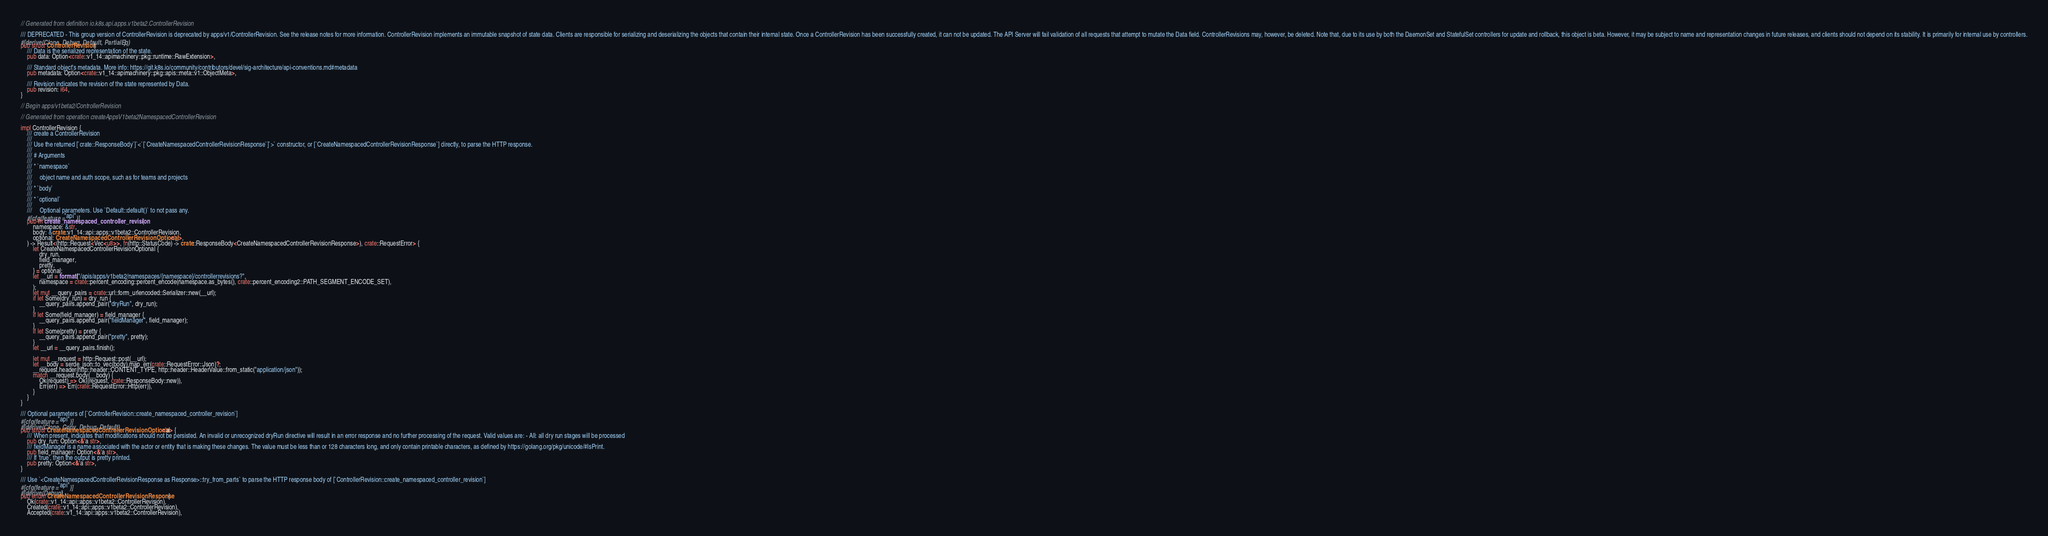<code> <loc_0><loc_0><loc_500><loc_500><_Rust_>// Generated from definition io.k8s.api.apps.v1beta2.ControllerRevision

/// DEPRECATED - This group version of ControllerRevision is deprecated by apps/v1/ControllerRevision. See the release notes for more information. ControllerRevision implements an immutable snapshot of state data. Clients are responsible for serializing and deserializing the objects that contain their internal state. Once a ControllerRevision has been successfully created, it can not be updated. The API Server will fail validation of all requests that attempt to mutate the Data field. ControllerRevisions may, however, be deleted. Note that, due to its use by both the DaemonSet and StatefulSet controllers for update and rollback, this object is beta. However, it may be subject to name and representation changes in future releases, and clients should not depend on its stability. It is primarily for internal use by controllers.
#[derive(Clone, Debug, Default, PartialEq)]
pub struct ControllerRevision {
    /// Data is the serialized representation of the state.
    pub data: Option<crate::v1_14::apimachinery::pkg::runtime::RawExtension>,

    /// Standard object's metadata. More info: https://git.k8s.io/community/contributors/devel/sig-architecture/api-conventions.md#metadata
    pub metadata: Option<crate::v1_14::apimachinery::pkg::apis::meta::v1::ObjectMeta>,

    /// Revision indicates the revision of the state represented by Data.
    pub revision: i64,
}

// Begin apps/v1beta2/ControllerRevision

// Generated from operation createAppsV1beta2NamespacedControllerRevision

impl ControllerRevision {
    /// create a ControllerRevision
    ///
    /// Use the returned [`crate::ResponseBody`]`<`[`CreateNamespacedControllerRevisionResponse`]`>` constructor, or [`CreateNamespacedControllerRevisionResponse`] directly, to parse the HTTP response.
    ///
    /// # Arguments
    ///
    /// * `namespace`
    ///
    ///     object name and auth scope, such as for teams and projects
    ///
    /// * `body`
    ///
    /// * `optional`
    ///
    ///     Optional parameters. Use `Default::default()` to not pass any.
    #[cfg(feature = "api")]
    pub fn create_namespaced_controller_revision(
        namespace: &str,
        body: &crate::v1_14::api::apps::v1beta2::ControllerRevision,
        optional: CreateNamespacedControllerRevisionOptional<'_>,
    ) -> Result<(http::Request<Vec<u8>>, fn(http::StatusCode) -> crate::ResponseBody<CreateNamespacedControllerRevisionResponse>), crate::RequestError> {
        let CreateNamespacedControllerRevisionOptional {
            dry_run,
            field_manager,
            pretty,
        } = optional;
        let __url = format!("/apis/apps/v1beta2/namespaces/{namespace}/controllerrevisions?",
            namespace = crate::percent_encoding::percent_encode(namespace.as_bytes(), crate::percent_encoding2::PATH_SEGMENT_ENCODE_SET),
        );
        let mut __query_pairs = crate::url::form_urlencoded::Serializer::new(__url);
        if let Some(dry_run) = dry_run {
            __query_pairs.append_pair("dryRun", dry_run);
        }
        if let Some(field_manager) = field_manager {
            __query_pairs.append_pair("fieldManager", field_manager);
        }
        if let Some(pretty) = pretty {
            __query_pairs.append_pair("pretty", pretty);
        }
        let __url = __query_pairs.finish();

        let mut __request = http::Request::post(__url);
        let __body = serde_json::to_vec(body).map_err(crate::RequestError::Json)?;
        __request.header(http::header::CONTENT_TYPE, http::header::HeaderValue::from_static("application/json"));
        match __request.body(__body) {
            Ok(request) => Ok((request, crate::ResponseBody::new)),
            Err(err) => Err(crate::RequestError::Http(err)),
        }
    }
}

/// Optional parameters of [`ControllerRevision::create_namespaced_controller_revision`]
#[cfg(feature = "api")]
#[derive(Clone, Copy, Debug, Default)]
pub struct CreateNamespacedControllerRevisionOptional<'a> {
    /// When present, indicates that modifications should not be persisted. An invalid or unrecognized dryRun directive will result in an error response and no further processing of the request. Valid values are: - All: all dry run stages will be processed
    pub dry_run: Option<&'a str>,
    /// fieldManager is a name associated with the actor or entity that is making these changes. The value must be less than or 128 characters long, and only contain printable characters, as defined by https://golang.org/pkg/unicode/#IsPrint.
    pub field_manager: Option<&'a str>,
    /// If 'true', then the output is pretty printed.
    pub pretty: Option<&'a str>,
}

/// Use `<CreateNamespacedControllerRevisionResponse as Response>::try_from_parts` to parse the HTTP response body of [`ControllerRevision::create_namespaced_controller_revision`]
#[cfg(feature = "api")]
#[derive(Debug)]
pub enum CreateNamespacedControllerRevisionResponse {
    Ok(crate::v1_14::api::apps::v1beta2::ControllerRevision),
    Created(crate::v1_14::api::apps::v1beta2::ControllerRevision),
    Accepted(crate::v1_14::api::apps::v1beta2::ControllerRevision),</code> 